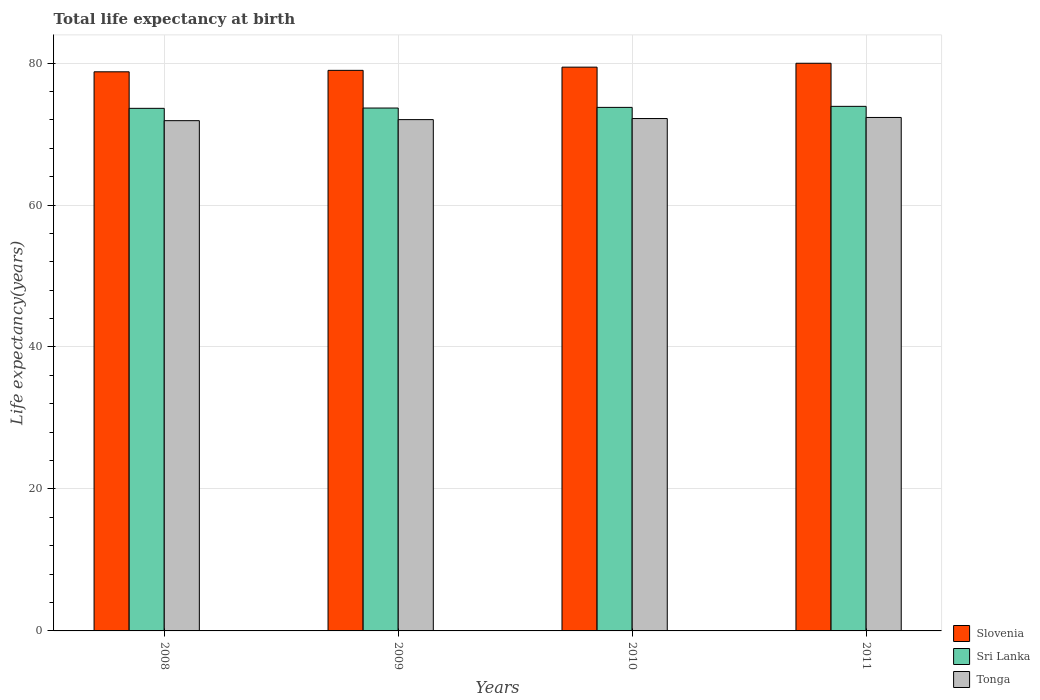Are the number of bars per tick equal to the number of legend labels?
Provide a short and direct response. Yes. What is the life expectancy at birth in in Slovenia in 2009?
Your response must be concise. 78.97. Across all years, what is the maximum life expectancy at birth in in Sri Lanka?
Your answer should be very brief. 73.9. Across all years, what is the minimum life expectancy at birth in in Slovenia?
Offer a very short reply. 78.77. In which year was the life expectancy at birth in in Sri Lanka minimum?
Keep it short and to the point. 2008. What is the total life expectancy at birth in in Sri Lanka in the graph?
Provide a succinct answer. 294.94. What is the difference between the life expectancy at birth in in Sri Lanka in 2008 and that in 2009?
Provide a short and direct response. -0.04. What is the difference between the life expectancy at birth in in Sri Lanka in 2008 and the life expectancy at birth in in Slovenia in 2010?
Offer a terse response. -5.8. What is the average life expectancy at birth in in Slovenia per year?
Provide a succinct answer. 79.28. In the year 2008, what is the difference between the life expectancy at birth in in Tonga and life expectancy at birth in in Sri Lanka?
Your response must be concise. -1.74. What is the ratio of the life expectancy at birth in in Tonga in 2008 to that in 2011?
Give a very brief answer. 0.99. What is the difference between the highest and the second highest life expectancy at birth in in Slovenia?
Your answer should be compact. 0.55. What is the difference between the highest and the lowest life expectancy at birth in in Tonga?
Give a very brief answer. 0.45. What does the 2nd bar from the left in 2009 represents?
Make the answer very short. Sri Lanka. What does the 3rd bar from the right in 2010 represents?
Your answer should be compact. Slovenia. How many years are there in the graph?
Make the answer very short. 4. What is the title of the graph?
Give a very brief answer. Total life expectancy at birth. What is the label or title of the X-axis?
Your answer should be compact. Years. What is the label or title of the Y-axis?
Your response must be concise. Life expectancy(years). What is the Life expectancy(years) in Slovenia in 2008?
Provide a succinct answer. 78.77. What is the Life expectancy(years) of Sri Lanka in 2008?
Offer a very short reply. 73.62. What is the Life expectancy(years) of Tonga in 2008?
Keep it short and to the point. 71.88. What is the Life expectancy(years) in Slovenia in 2009?
Offer a terse response. 78.97. What is the Life expectancy(years) of Sri Lanka in 2009?
Provide a succinct answer. 73.66. What is the Life expectancy(years) of Tonga in 2009?
Offer a very short reply. 72.03. What is the Life expectancy(years) of Slovenia in 2010?
Keep it short and to the point. 79.42. What is the Life expectancy(years) of Sri Lanka in 2010?
Give a very brief answer. 73.76. What is the Life expectancy(years) in Tonga in 2010?
Offer a very short reply. 72.18. What is the Life expectancy(years) in Slovenia in 2011?
Your response must be concise. 79.97. What is the Life expectancy(years) of Sri Lanka in 2011?
Provide a short and direct response. 73.9. What is the Life expectancy(years) in Tonga in 2011?
Give a very brief answer. 72.33. Across all years, what is the maximum Life expectancy(years) in Slovenia?
Offer a very short reply. 79.97. Across all years, what is the maximum Life expectancy(years) of Sri Lanka?
Your response must be concise. 73.9. Across all years, what is the maximum Life expectancy(years) of Tonga?
Your answer should be very brief. 72.33. Across all years, what is the minimum Life expectancy(years) in Slovenia?
Offer a terse response. 78.77. Across all years, what is the minimum Life expectancy(years) of Sri Lanka?
Make the answer very short. 73.62. Across all years, what is the minimum Life expectancy(years) of Tonga?
Give a very brief answer. 71.88. What is the total Life expectancy(years) of Slovenia in the graph?
Give a very brief answer. 317.13. What is the total Life expectancy(years) in Sri Lanka in the graph?
Make the answer very short. 294.94. What is the total Life expectancy(years) of Tonga in the graph?
Offer a very short reply. 288.43. What is the difference between the Life expectancy(years) of Slovenia in 2008 and that in 2009?
Provide a succinct answer. -0.2. What is the difference between the Life expectancy(years) in Sri Lanka in 2008 and that in 2009?
Give a very brief answer. -0.04. What is the difference between the Life expectancy(years) of Tonga in 2008 and that in 2009?
Keep it short and to the point. -0.15. What is the difference between the Life expectancy(years) in Slovenia in 2008 and that in 2010?
Ensure brevity in your answer.  -0.66. What is the difference between the Life expectancy(years) of Sri Lanka in 2008 and that in 2010?
Ensure brevity in your answer.  -0.14. What is the difference between the Life expectancy(years) in Tonga in 2008 and that in 2010?
Give a very brief answer. -0.3. What is the difference between the Life expectancy(years) of Slovenia in 2008 and that in 2011?
Give a very brief answer. -1.2. What is the difference between the Life expectancy(years) in Sri Lanka in 2008 and that in 2011?
Give a very brief answer. -0.28. What is the difference between the Life expectancy(years) of Tonga in 2008 and that in 2011?
Your response must be concise. -0.45. What is the difference between the Life expectancy(years) of Slovenia in 2009 and that in 2010?
Provide a succinct answer. -0.45. What is the difference between the Life expectancy(years) in Sri Lanka in 2009 and that in 2010?
Ensure brevity in your answer.  -0.09. What is the difference between the Life expectancy(years) of Tonga in 2009 and that in 2010?
Your response must be concise. -0.15. What is the difference between the Life expectancy(years) of Slovenia in 2009 and that in 2011?
Make the answer very short. -1. What is the difference between the Life expectancy(years) of Sri Lanka in 2009 and that in 2011?
Make the answer very short. -0.24. What is the difference between the Life expectancy(years) in Tonga in 2009 and that in 2011?
Offer a very short reply. -0.3. What is the difference between the Life expectancy(years) in Slovenia in 2010 and that in 2011?
Your answer should be compact. -0.55. What is the difference between the Life expectancy(years) in Sri Lanka in 2010 and that in 2011?
Provide a succinct answer. -0.14. What is the difference between the Life expectancy(years) in Tonga in 2010 and that in 2011?
Offer a very short reply. -0.15. What is the difference between the Life expectancy(years) of Slovenia in 2008 and the Life expectancy(years) of Sri Lanka in 2009?
Provide a succinct answer. 5.1. What is the difference between the Life expectancy(years) of Slovenia in 2008 and the Life expectancy(years) of Tonga in 2009?
Provide a short and direct response. 6.73. What is the difference between the Life expectancy(years) in Sri Lanka in 2008 and the Life expectancy(years) in Tonga in 2009?
Provide a succinct answer. 1.59. What is the difference between the Life expectancy(years) in Slovenia in 2008 and the Life expectancy(years) in Sri Lanka in 2010?
Your response must be concise. 5.01. What is the difference between the Life expectancy(years) in Slovenia in 2008 and the Life expectancy(years) in Tonga in 2010?
Provide a short and direct response. 6.58. What is the difference between the Life expectancy(years) of Sri Lanka in 2008 and the Life expectancy(years) of Tonga in 2010?
Ensure brevity in your answer.  1.44. What is the difference between the Life expectancy(years) of Slovenia in 2008 and the Life expectancy(years) of Sri Lanka in 2011?
Make the answer very short. 4.87. What is the difference between the Life expectancy(years) in Slovenia in 2008 and the Life expectancy(years) in Tonga in 2011?
Your answer should be very brief. 6.43. What is the difference between the Life expectancy(years) of Sri Lanka in 2008 and the Life expectancy(years) of Tonga in 2011?
Offer a very short reply. 1.29. What is the difference between the Life expectancy(years) of Slovenia in 2009 and the Life expectancy(years) of Sri Lanka in 2010?
Ensure brevity in your answer.  5.22. What is the difference between the Life expectancy(years) in Slovenia in 2009 and the Life expectancy(years) in Tonga in 2010?
Ensure brevity in your answer.  6.79. What is the difference between the Life expectancy(years) of Sri Lanka in 2009 and the Life expectancy(years) of Tonga in 2010?
Your answer should be compact. 1.48. What is the difference between the Life expectancy(years) of Slovenia in 2009 and the Life expectancy(years) of Sri Lanka in 2011?
Give a very brief answer. 5.07. What is the difference between the Life expectancy(years) in Slovenia in 2009 and the Life expectancy(years) in Tonga in 2011?
Make the answer very short. 6.64. What is the difference between the Life expectancy(years) of Sri Lanka in 2009 and the Life expectancy(years) of Tonga in 2011?
Your answer should be very brief. 1.33. What is the difference between the Life expectancy(years) in Slovenia in 2010 and the Life expectancy(years) in Sri Lanka in 2011?
Offer a terse response. 5.52. What is the difference between the Life expectancy(years) of Slovenia in 2010 and the Life expectancy(years) of Tonga in 2011?
Make the answer very short. 7.09. What is the difference between the Life expectancy(years) in Sri Lanka in 2010 and the Life expectancy(years) in Tonga in 2011?
Your answer should be compact. 1.42. What is the average Life expectancy(years) in Slovenia per year?
Ensure brevity in your answer.  79.28. What is the average Life expectancy(years) of Sri Lanka per year?
Offer a very short reply. 73.73. What is the average Life expectancy(years) of Tonga per year?
Your answer should be compact. 72.11. In the year 2008, what is the difference between the Life expectancy(years) in Slovenia and Life expectancy(years) in Sri Lanka?
Ensure brevity in your answer.  5.15. In the year 2008, what is the difference between the Life expectancy(years) of Slovenia and Life expectancy(years) of Tonga?
Your response must be concise. 6.88. In the year 2008, what is the difference between the Life expectancy(years) in Sri Lanka and Life expectancy(years) in Tonga?
Ensure brevity in your answer.  1.74. In the year 2009, what is the difference between the Life expectancy(years) in Slovenia and Life expectancy(years) in Sri Lanka?
Give a very brief answer. 5.31. In the year 2009, what is the difference between the Life expectancy(years) of Slovenia and Life expectancy(years) of Tonga?
Your answer should be compact. 6.94. In the year 2009, what is the difference between the Life expectancy(years) of Sri Lanka and Life expectancy(years) of Tonga?
Provide a short and direct response. 1.63. In the year 2010, what is the difference between the Life expectancy(years) in Slovenia and Life expectancy(years) in Sri Lanka?
Offer a terse response. 5.67. In the year 2010, what is the difference between the Life expectancy(years) in Slovenia and Life expectancy(years) in Tonga?
Your response must be concise. 7.24. In the year 2010, what is the difference between the Life expectancy(years) in Sri Lanka and Life expectancy(years) in Tonga?
Ensure brevity in your answer.  1.57. In the year 2011, what is the difference between the Life expectancy(years) in Slovenia and Life expectancy(years) in Sri Lanka?
Provide a short and direct response. 6.07. In the year 2011, what is the difference between the Life expectancy(years) in Slovenia and Life expectancy(years) in Tonga?
Ensure brevity in your answer.  7.64. In the year 2011, what is the difference between the Life expectancy(years) in Sri Lanka and Life expectancy(years) in Tonga?
Your answer should be very brief. 1.56. What is the ratio of the Life expectancy(years) in Sri Lanka in 2008 to that in 2009?
Your answer should be very brief. 1. What is the ratio of the Life expectancy(years) of Slovenia in 2008 to that in 2010?
Ensure brevity in your answer.  0.99. What is the ratio of the Life expectancy(years) in Sri Lanka in 2008 to that in 2010?
Provide a succinct answer. 1. What is the ratio of the Life expectancy(years) of Tonga in 2008 to that in 2010?
Your answer should be very brief. 1. What is the ratio of the Life expectancy(years) in Slovenia in 2008 to that in 2011?
Your response must be concise. 0.98. What is the ratio of the Life expectancy(years) of Tonga in 2008 to that in 2011?
Your answer should be very brief. 0.99. What is the ratio of the Life expectancy(years) in Sri Lanka in 2009 to that in 2010?
Keep it short and to the point. 1. What is the ratio of the Life expectancy(years) in Tonga in 2009 to that in 2010?
Make the answer very short. 1. What is the ratio of the Life expectancy(years) in Slovenia in 2009 to that in 2011?
Offer a terse response. 0.99. What is the difference between the highest and the second highest Life expectancy(years) of Slovenia?
Your answer should be compact. 0.55. What is the difference between the highest and the second highest Life expectancy(years) of Sri Lanka?
Your answer should be very brief. 0.14. What is the difference between the highest and the second highest Life expectancy(years) of Tonga?
Provide a short and direct response. 0.15. What is the difference between the highest and the lowest Life expectancy(years) in Slovenia?
Your response must be concise. 1.2. What is the difference between the highest and the lowest Life expectancy(years) in Sri Lanka?
Give a very brief answer. 0.28. What is the difference between the highest and the lowest Life expectancy(years) in Tonga?
Keep it short and to the point. 0.45. 